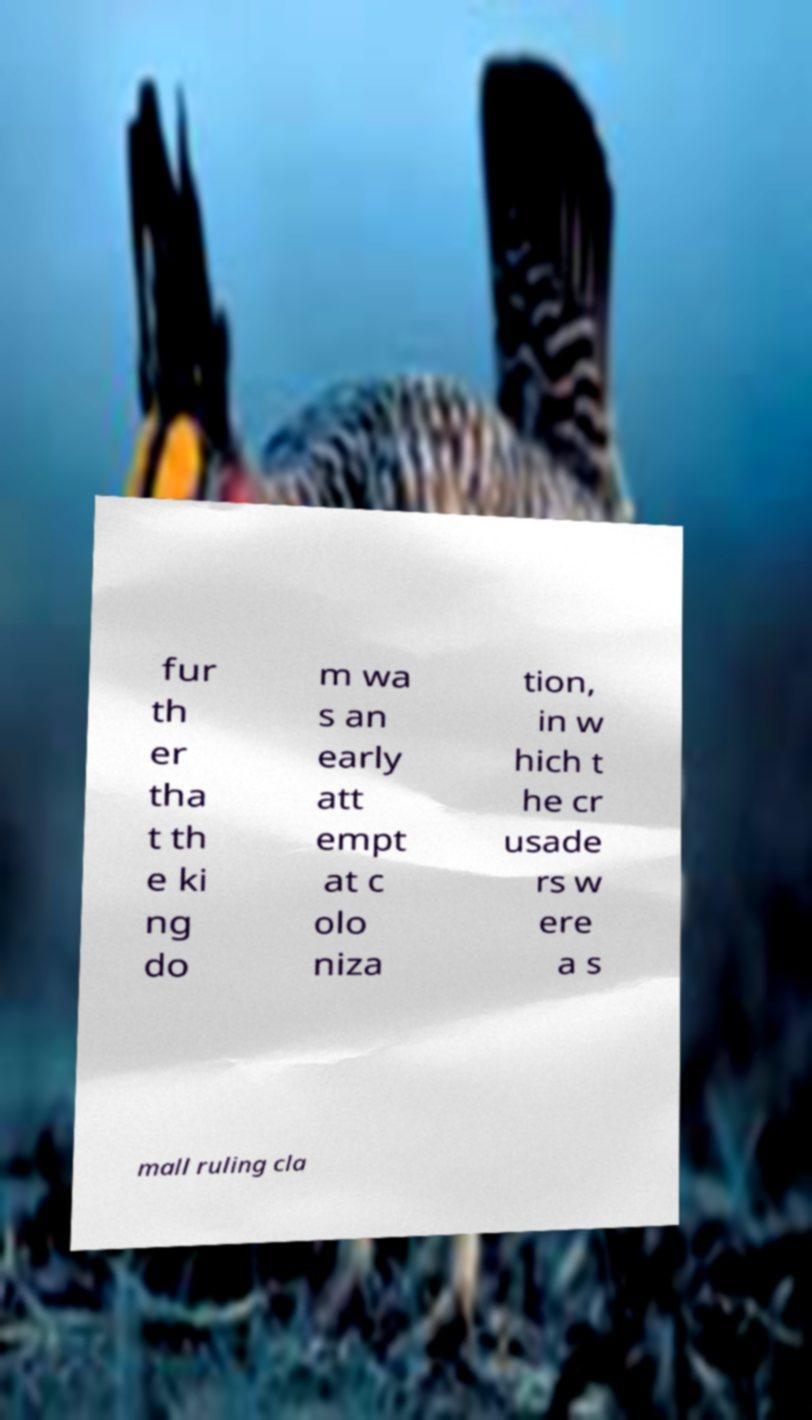Could you assist in decoding the text presented in this image and type it out clearly? fur th er tha t th e ki ng do m wa s an early att empt at c olo niza tion, in w hich t he cr usade rs w ere a s mall ruling cla 